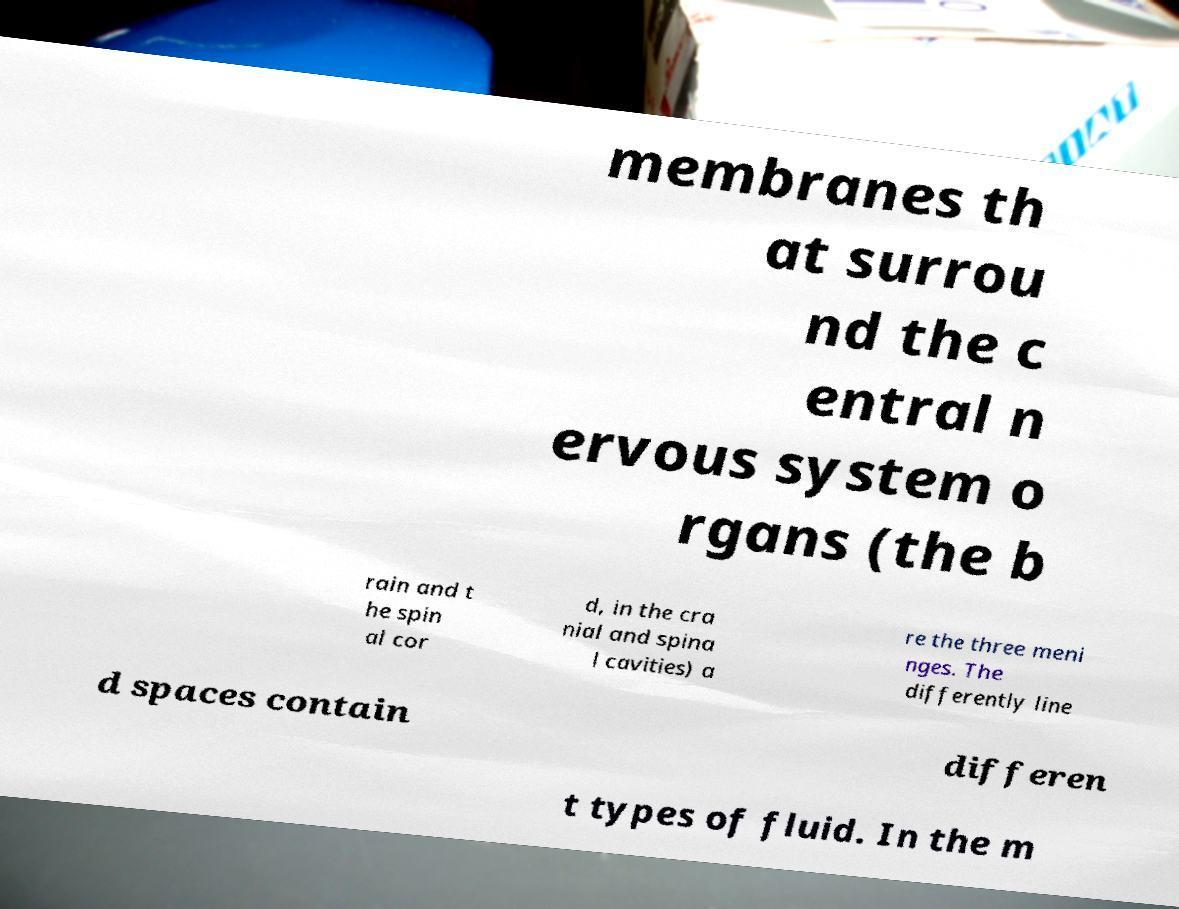Could you extract and type out the text from this image? membranes th at surrou nd the c entral n ervous system o rgans (the b rain and t he spin al cor d, in the cra nial and spina l cavities) a re the three meni nges. The differently line d spaces contain differen t types of fluid. In the m 